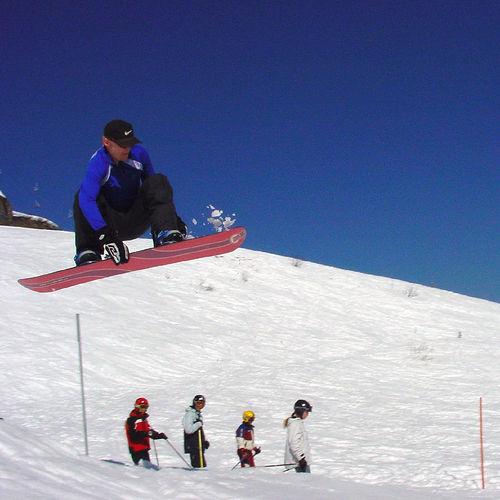What is written on the bottom of the board?
Quick response, please. Nothing. How many people are spectating the snowboarder?
Keep it brief. 4. What color is the snowboard?
Concise answer only. Red. What season is it?
Quick response, please. Winter. Did the guy on the snowboard just fall?
Keep it brief. No. 